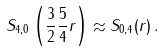<formula> <loc_0><loc_0><loc_500><loc_500>S _ { 4 , 0 } \left ( \frac { 3 } { 2 } \frac { 5 } { 4 } r \right ) \approx S _ { 0 , 4 } ( r ) \, .</formula> 